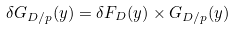Convert formula to latex. <formula><loc_0><loc_0><loc_500><loc_500>\delta G _ { D / p } ( y ) = \delta F _ { D } ( y ) \times G _ { D / p } ( y )</formula> 